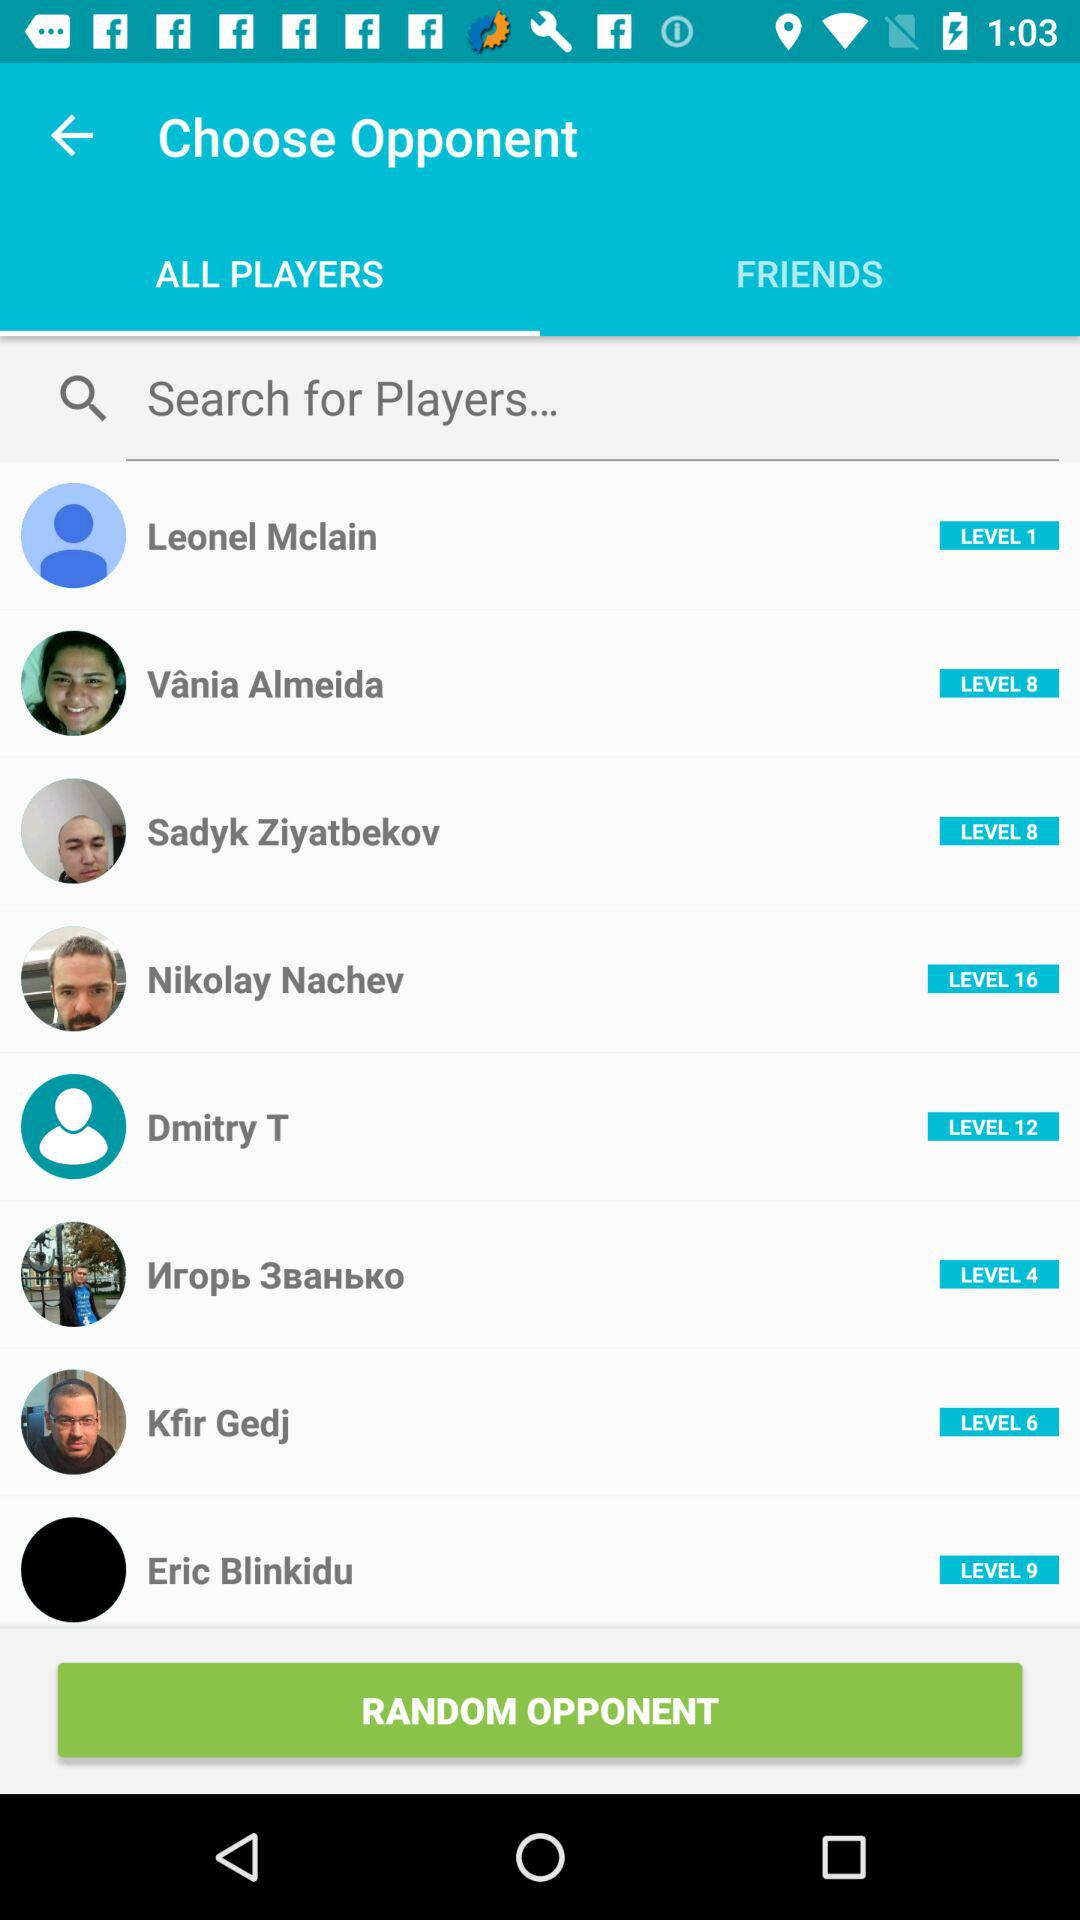What tab is selected? The selected tab is "ALL PLAYERS". 